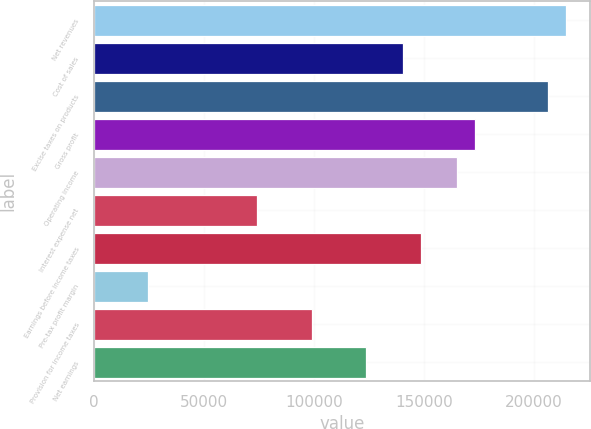<chart> <loc_0><loc_0><loc_500><loc_500><bar_chart><fcel>Net revenues<fcel>Cost of sales<fcel>Excise taxes on products<fcel>Gross profit<fcel>Operating income<fcel>Interest expense net<fcel>Earnings before income taxes<fcel>Pre-tax profit margin<fcel>Provision for income taxes<fcel>Net earnings<nl><fcel>214494<fcel>140247<fcel>206244<fcel>173246<fcel>164996<fcel>74250.4<fcel>148497<fcel>24752.7<fcel>98999.2<fcel>123748<nl></chart> 